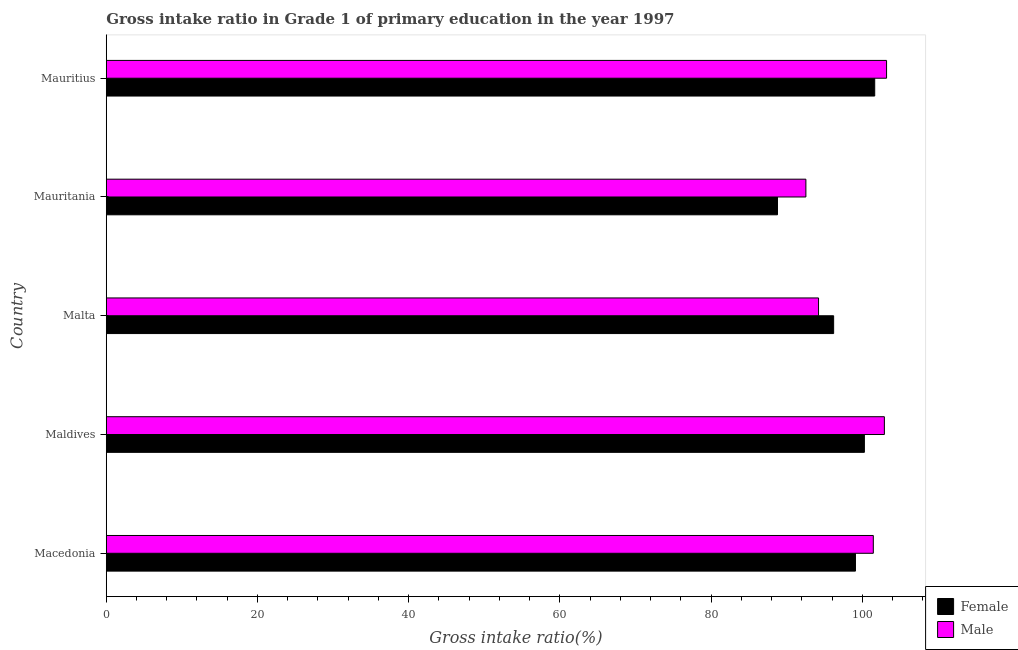How many groups of bars are there?
Make the answer very short. 5. Are the number of bars per tick equal to the number of legend labels?
Ensure brevity in your answer.  Yes. Are the number of bars on each tick of the Y-axis equal?
Ensure brevity in your answer.  Yes. How many bars are there on the 5th tick from the top?
Make the answer very short. 2. What is the label of the 3rd group of bars from the top?
Your answer should be very brief. Malta. In how many cases, is the number of bars for a given country not equal to the number of legend labels?
Provide a short and direct response. 0. What is the gross intake ratio(male) in Mauritania?
Offer a terse response. 92.54. Across all countries, what is the maximum gross intake ratio(female)?
Give a very brief answer. 101.65. Across all countries, what is the minimum gross intake ratio(female)?
Provide a succinct answer. 88.78. In which country was the gross intake ratio(female) maximum?
Give a very brief answer. Mauritius. In which country was the gross intake ratio(female) minimum?
Keep it short and to the point. Mauritania. What is the total gross intake ratio(male) in the graph?
Give a very brief answer. 494.35. What is the difference between the gross intake ratio(male) in Macedonia and that in Mauritania?
Your answer should be compact. 8.92. What is the difference between the gross intake ratio(male) in Maldives and the gross intake ratio(female) in Macedonia?
Your answer should be compact. 3.82. What is the average gross intake ratio(female) per country?
Provide a succinct answer. 97.2. What is the difference between the gross intake ratio(male) and gross intake ratio(female) in Mauritius?
Offer a very short reply. 1.57. Is the difference between the gross intake ratio(male) in Macedonia and Maldives greater than the difference between the gross intake ratio(female) in Macedonia and Maldives?
Offer a very short reply. No. What is the difference between the highest and the second highest gross intake ratio(male)?
Your answer should be very brief. 0.29. What is the difference between the highest and the lowest gross intake ratio(male)?
Provide a succinct answer. 10.67. In how many countries, is the gross intake ratio(female) greater than the average gross intake ratio(female) taken over all countries?
Your response must be concise. 3. Is the sum of the gross intake ratio(female) in Malta and Mauritius greater than the maximum gross intake ratio(male) across all countries?
Provide a short and direct response. Yes. What does the 1st bar from the top in Maldives represents?
Keep it short and to the point. Male. What does the 2nd bar from the bottom in Mauritius represents?
Your response must be concise. Male. How many bars are there?
Offer a very short reply. 10. Are all the bars in the graph horizontal?
Make the answer very short. Yes. How many countries are there in the graph?
Give a very brief answer. 5. What is the difference between two consecutive major ticks on the X-axis?
Keep it short and to the point. 20. Are the values on the major ticks of X-axis written in scientific E-notation?
Ensure brevity in your answer.  No. Where does the legend appear in the graph?
Offer a very short reply. Bottom right. How many legend labels are there?
Keep it short and to the point. 2. How are the legend labels stacked?
Your answer should be very brief. Vertical. What is the title of the graph?
Keep it short and to the point. Gross intake ratio in Grade 1 of primary education in the year 1997. Does "Revenue" appear as one of the legend labels in the graph?
Give a very brief answer. No. What is the label or title of the X-axis?
Your answer should be compact. Gross intake ratio(%). What is the label or title of the Y-axis?
Your response must be concise. Country. What is the Gross intake ratio(%) in Female in Macedonia?
Make the answer very short. 99.1. What is the Gross intake ratio(%) in Male in Macedonia?
Make the answer very short. 101.46. What is the Gross intake ratio(%) of Female in Maldives?
Your answer should be compact. 100.28. What is the Gross intake ratio(%) in Male in Maldives?
Ensure brevity in your answer.  102.92. What is the Gross intake ratio(%) of Female in Malta?
Your response must be concise. 96.21. What is the Gross intake ratio(%) of Male in Malta?
Your answer should be compact. 94.22. What is the Gross intake ratio(%) of Female in Mauritania?
Your answer should be compact. 88.78. What is the Gross intake ratio(%) of Male in Mauritania?
Provide a succinct answer. 92.54. What is the Gross intake ratio(%) in Female in Mauritius?
Offer a very short reply. 101.65. What is the Gross intake ratio(%) of Male in Mauritius?
Offer a terse response. 103.21. Across all countries, what is the maximum Gross intake ratio(%) of Female?
Make the answer very short. 101.65. Across all countries, what is the maximum Gross intake ratio(%) of Male?
Your response must be concise. 103.21. Across all countries, what is the minimum Gross intake ratio(%) in Female?
Offer a very short reply. 88.78. Across all countries, what is the minimum Gross intake ratio(%) of Male?
Ensure brevity in your answer.  92.54. What is the total Gross intake ratio(%) of Female in the graph?
Offer a terse response. 486.02. What is the total Gross intake ratio(%) in Male in the graph?
Give a very brief answer. 494.35. What is the difference between the Gross intake ratio(%) in Female in Macedonia and that in Maldives?
Keep it short and to the point. -1.18. What is the difference between the Gross intake ratio(%) in Male in Macedonia and that in Maldives?
Provide a succinct answer. -1.46. What is the difference between the Gross intake ratio(%) of Female in Macedonia and that in Malta?
Keep it short and to the point. 2.89. What is the difference between the Gross intake ratio(%) of Male in Macedonia and that in Malta?
Provide a succinct answer. 7.24. What is the difference between the Gross intake ratio(%) of Female in Macedonia and that in Mauritania?
Your answer should be very brief. 10.32. What is the difference between the Gross intake ratio(%) of Male in Macedonia and that in Mauritania?
Ensure brevity in your answer.  8.92. What is the difference between the Gross intake ratio(%) in Female in Macedonia and that in Mauritius?
Your answer should be very brief. -2.55. What is the difference between the Gross intake ratio(%) in Male in Macedonia and that in Mauritius?
Your answer should be very brief. -1.75. What is the difference between the Gross intake ratio(%) of Female in Maldives and that in Malta?
Your answer should be very brief. 4.07. What is the difference between the Gross intake ratio(%) in Male in Maldives and that in Malta?
Your answer should be very brief. 8.71. What is the difference between the Gross intake ratio(%) in Female in Maldives and that in Mauritania?
Offer a terse response. 11.5. What is the difference between the Gross intake ratio(%) in Male in Maldives and that in Mauritania?
Offer a very short reply. 10.38. What is the difference between the Gross intake ratio(%) in Female in Maldives and that in Mauritius?
Give a very brief answer. -1.37. What is the difference between the Gross intake ratio(%) of Male in Maldives and that in Mauritius?
Give a very brief answer. -0.29. What is the difference between the Gross intake ratio(%) of Female in Malta and that in Mauritania?
Your response must be concise. 7.43. What is the difference between the Gross intake ratio(%) of Male in Malta and that in Mauritania?
Provide a short and direct response. 1.67. What is the difference between the Gross intake ratio(%) of Female in Malta and that in Mauritius?
Your answer should be very brief. -5.43. What is the difference between the Gross intake ratio(%) in Male in Malta and that in Mauritius?
Make the answer very short. -9. What is the difference between the Gross intake ratio(%) of Female in Mauritania and that in Mauritius?
Offer a terse response. -12.86. What is the difference between the Gross intake ratio(%) of Male in Mauritania and that in Mauritius?
Ensure brevity in your answer.  -10.67. What is the difference between the Gross intake ratio(%) of Female in Macedonia and the Gross intake ratio(%) of Male in Maldives?
Keep it short and to the point. -3.82. What is the difference between the Gross intake ratio(%) of Female in Macedonia and the Gross intake ratio(%) of Male in Malta?
Provide a short and direct response. 4.88. What is the difference between the Gross intake ratio(%) in Female in Macedonia and the Gross intake ratio(%) in Male in Mauritania?
Give a very brief answer. 6.56. What is the difference between the Gross intake ratio(%) of Female in Macedonia and the Gross intake ratio(%) of Male in Mauritius?
Offer a terse response. -4.11. What is the difference between the Gross intake ratio(%) of Female in Maldives and the Gross intake ratio(%) of Male in Malta?
Your answer should be very brief. 6.06. What is the difference between the Gross intake ratio(%) of Female in Maldives and the Gross intake ratio(%) of Male in Mauritania?
Make the answer very short. 7.74. What is the difference between the Gross intake ratio(%) in Female in Maldives and the Gross intake ratio(%) in Male in Mauritius?
Keep it short and to the point. -2.93. What is the difference between the Gross intake ratio(%) in Female in Malta and the Gross intake ratio(%) in Male in Mauritania?
Your answer should be compact. 3.67. What is the difference between the Gross intake ratio(%) in Female in Malta and the Gross intake ratio(%) in Male in Mauritius?
Keep it short and to the point. -7. What is the difference between the Gross intake ratio(%) of Female in Mauritania and the Gross intake ratio(%) of Male in Mauritius?
Make the answer very short. -14.43. What is the average Gross intake ratio(%) in Female per country?
Keep it short and to the point. 97.2. What is the average Gross intake ratio(%) in Male per country?
Your answer should be compact. 98.87. What is the difference between the Gross intake ratio(%) in Female and Gross intake ratio(%) in Male in Macedonia?
Keep it short and to the point. -2.36. What is the difference between the Gross intake ratio(%) in Female and Gross intake ratio(%) in Male in Maldives?
Offer a terse response. -2.64. What is the difference between the Gross intake ratio(%) of Female and Gross intake ratio(%) of Male in Malta?
Your response must be concise. 2. What is the difference between the Gross intake ratio(%) of Female and Gross intake ratio(%) of Male in Mauritania?
Provide a short and direct response. -3.76. What is the difference between the Gross intake ratio(%) of Female and Gross intake ratio(%) of Male in Mauritius?
Give a very brief answer. -1.57. What is the ratio of the Gross intake ratio(%) of Male in Macedonia to that in Maldives?
Provide a short and direct response. 0.99. What is the ratio of the Gross intake ratio(%) of Female in Macedonia to that in Malta?
Keep it short and to the point. 1.03. What is the ratio of the Gross intake ratio(%) of Female in Macedonia to that in Mauritania?
Your answer should be compact. 1.12. What is the ratio of the Gross intake ratio(%) of Male in Macedonia to that in Mauritania?
Your answer should be very brief. 1.1. What is the ratio of the Gross intake ratio(%) of Female in Macedonia to that in Mauritius?
Your answer should be very brief. 0.97. What is the ratio of the Gross intake ratio(%) in Male in Macedonia to that in Mauritius?
Ensure brevity in your answer.  0.98. What is the ratio of the Gross intake ratio(%) in Female in Maldives to that in Malta?
Ensure brevity in your answer.  1.04. What is the ratio of the Gross intake ratio(%) of Male in Maldives to that in Malta?
Your answer should be compact. 1.09. What is the ratio of the Gross intake ratio(%) of Female in Maldives to that in Mauritania?
Your answer should be very brief. 1.13. What is the ratio of the Gross intake ratio(%) of Male in Maldives to that in Mauritania?
Ensure brevity in your answer.  1.11. What is the ratio of the Gross intake ratio(%) in Female in Maldives to that in Mauritius?
Your response must be concise. 0.99. What is the ratio of the Gross intake ratio(%) of Female in Malta to that in Mauritania?
Provide a succinct answer. 1.08. What is the ratio of the Gross intake ratio(%) in Male in Malta to that in Mauritania?
Give a very brief answer. 1.02. What is the ratio of the Gross intake ratio(%) in Female in Malta to that in Mauritius?
Provide a succinct answer. 0.95. What is the ratio of the Gross intake ratio(%) of Male in Malta to that in Mauritius?
Give a very brief answer. 0.91. What is the ratio of the Gross intake ratio(%) of Female in Mauritania to that in Mauritius?
Offer a very short reply. 0.87. What is the ratio of the Gross intake ratio(%) of Male in Mauritania to that in Mauritius?
Your response must be concise. 0.9. What is the difference between the highest and the second highest Gross intake ratio(%) in Female?
Provide a short and direct response. 1.37. What is the difference between the highest and the second highest Gross intake ratio(%) in Male?
Ensure brevity in your answer.  0.29. What is the difference between the highest and the lowest Gross intake ratio(%) in Female?
Provide a succinct answer. 12.86. What is the difference between the highest and the lowest Gross intake ratio(%) in Male?
Provide a succinct answer. 10.67. 